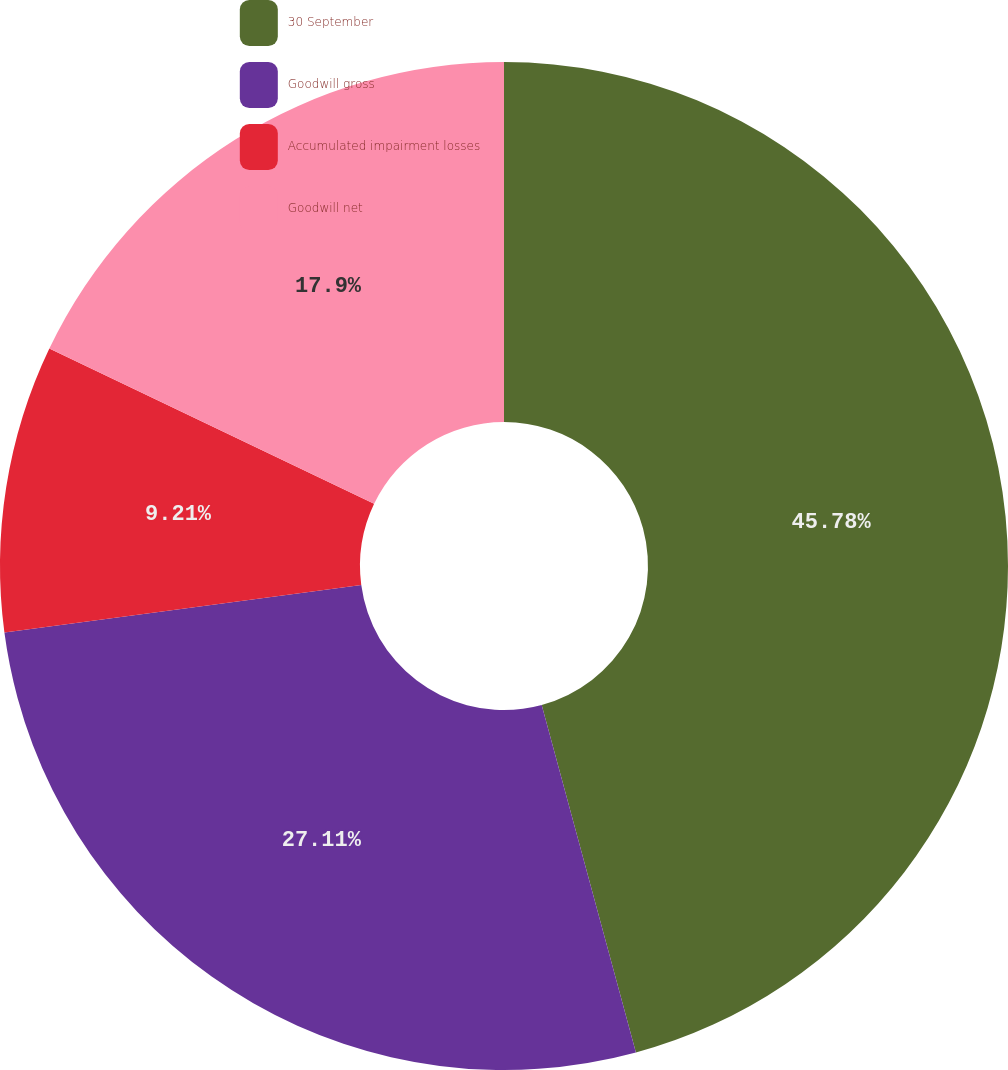Convert chart to OTSL. <chart><loc_0><loc_0><loc_500><loc_500><pie_chart><fcel>30 September<fcel>Goodwill gross<fcel>Accumulated impairment losses<fcel>Goodwill net<nl><fcel>45.79%<fcel>27.11%<fcel>9.21%<fcel>17.9%<nl></chart> 